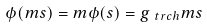<formula> <loc_0><loc_0><loc_500><loc_500>\phi ( m s ) = m \phi ( s ) = g _ { \ t r c h } m s</formula> 